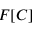<formula> <loc_0><loc_0><loc_500><loc_500>F [ C ]</formula> 